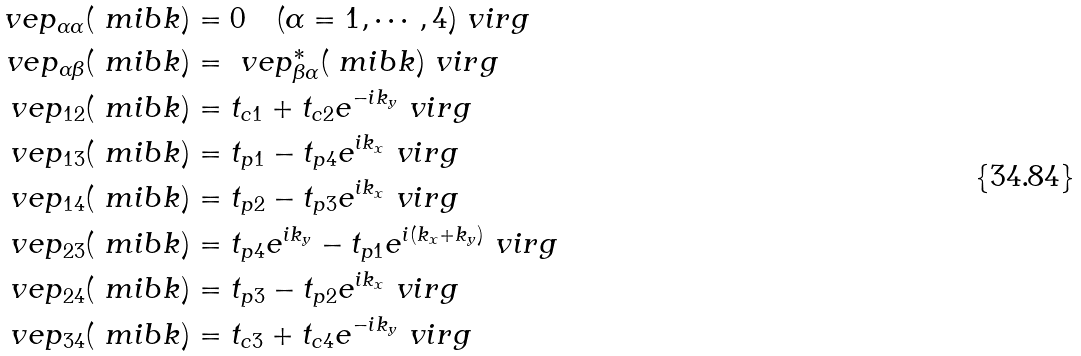Convert formula to latex. <formula><loc_0><loc_0><loc_500><loc_500>\ v e p _ { \alpha \alpha } ( \ m i b { k } ) & = 0 \quad ( \alpha = 1 , \cdots , 4 ) \ v i r g \\ \ v e p _ { \alpha \beta } ( \ m i b { k } ) & = \ v e p _ { \beta \alpha } ^ { * } ( \ m i b { k } ) \ v i r g \\ \ v e p _ { 1 2 } ( \ m i b { k } ) & = t _ { c 1 } + t _ { c 2 } e ^ { - i k _ { y } } \ v i r g \\ \ v e p _ { 1 3 } ( \ m i b { k } ) & = t _ { p 1 } - t _ { p 4 } e ^ { i k _ { x } } \ v i r g \\ \ v e p _ { 1 4 } ( \ m i b { k } ) & = t _ { p 2 } - t _ { p 3 } e ^ { i k _ { x } } \ v i r g \\ \ v e p _ { 2 3 } ( \ m i b { k } ) & = t _ { p 4 } e ^ { i k _ { y } } - t _ { p 1 } e ^ { i ( k _ { x } + k _ { y } ) } \ v i r g \\ \ v e p _ { 2 4 } ( \ m i b { k } ) & = t _ { p 3 } - t _ { p 2 } e ^ { i k _ { x } } \ v i r g \\ \ v e p _ { 3 4 } ( \ m i b { k } ) & = t _ { c 3 } + t _ { c 4 } e ^ { - i k _ { y } } \ v i r g</formula> 